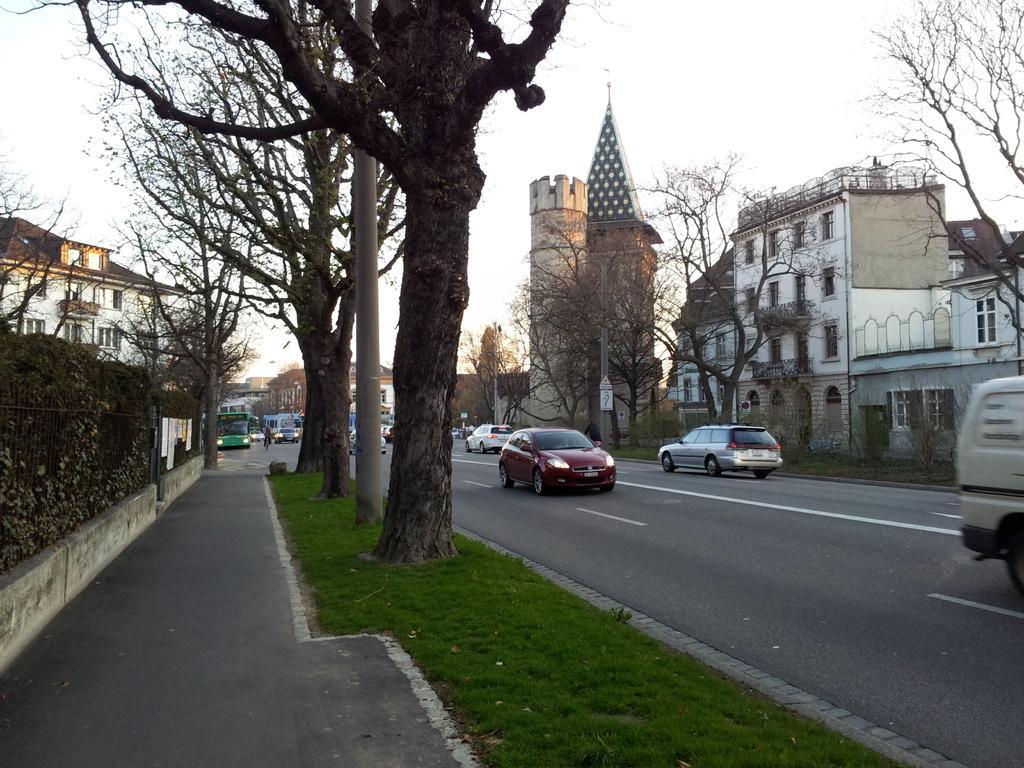Could you give a brief overview of what you see in this image? In this picture we can see few vehicles on the road, beside to the road we can find few trees, buildings and poles. 